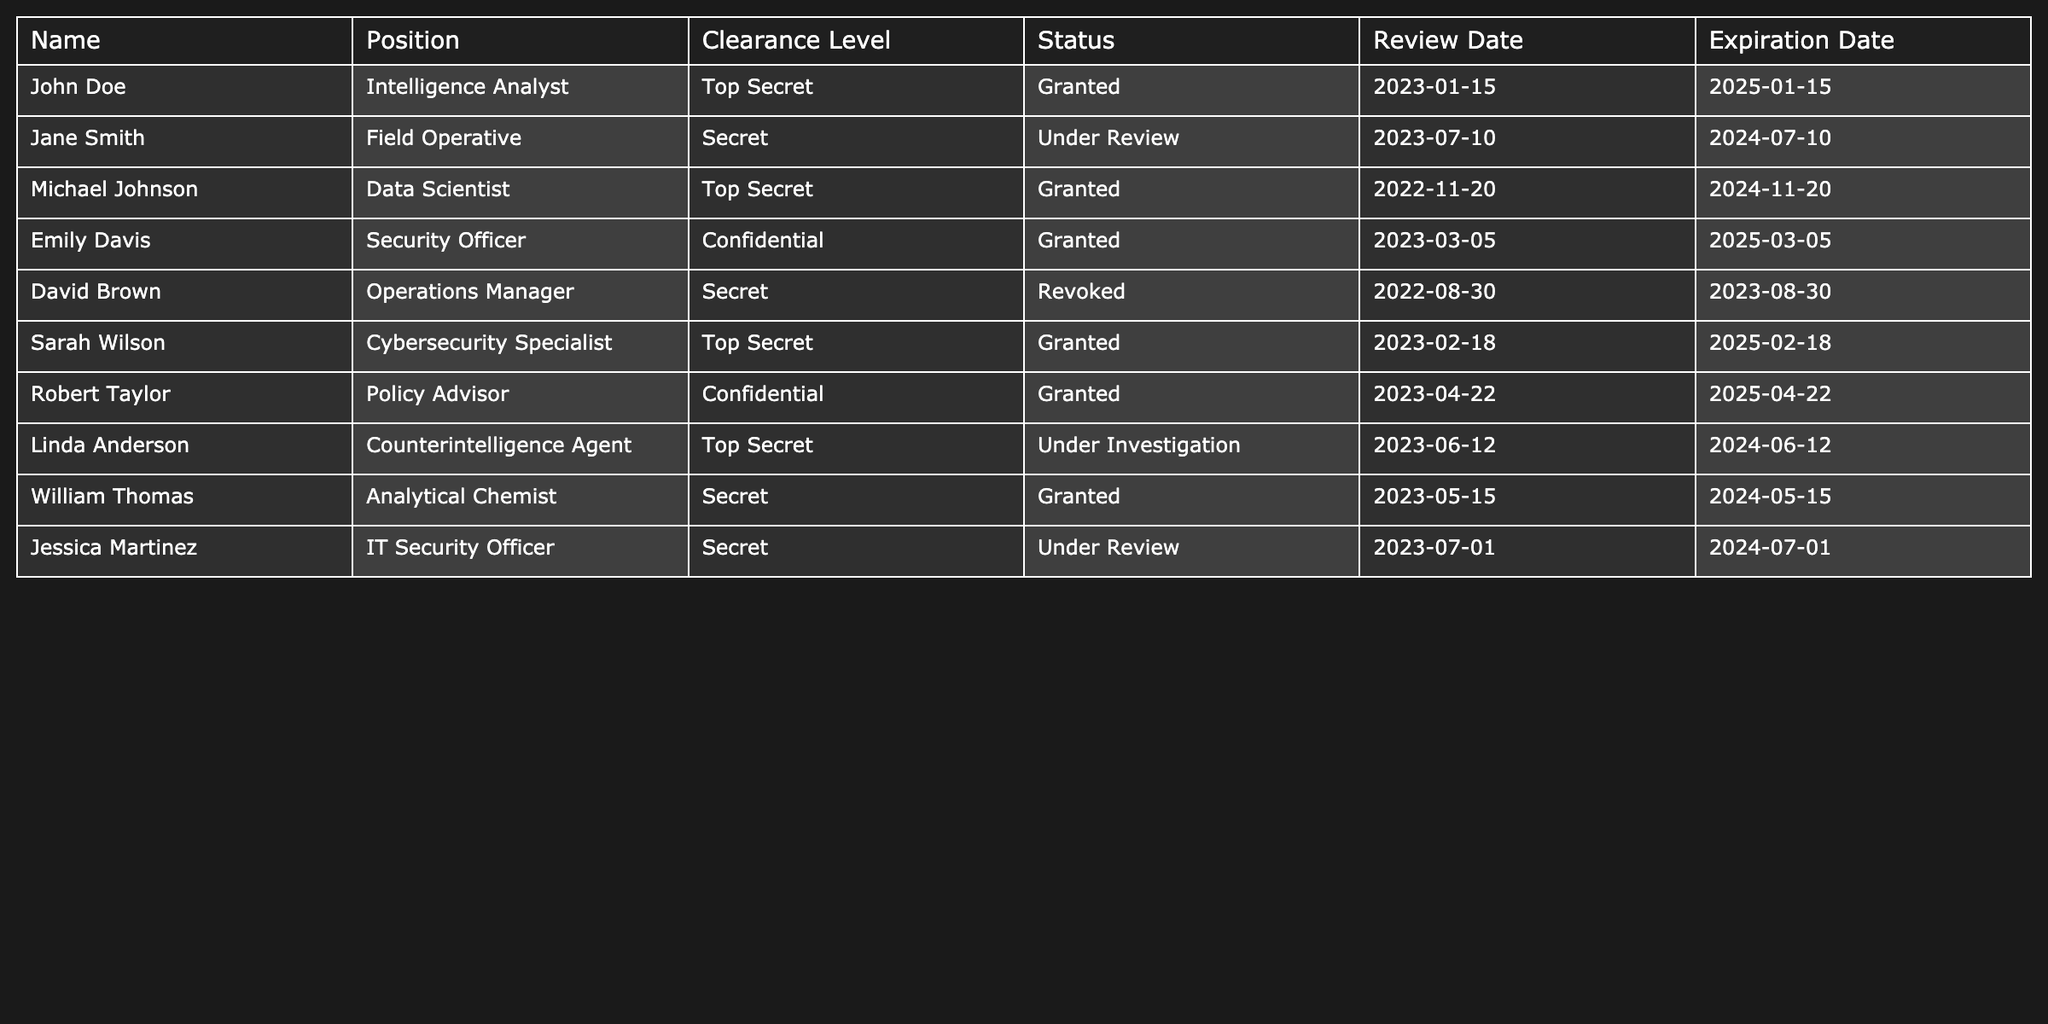What is the clearance level of Emily Davis? The table indicates that Emily Davis holds the position of Security Officer, and her clearance level is listed as Confidential.
Answer: Confidential How many personnel have a clearance status of 'Granted'? By reviewing the table, I can count the entries where the status is 'Granted'. Those personnel are John Doe, Michael Johnson, Emily Davis, Sarah Wilson, Robert Taylor, and William Thomas, making a total of 6 individuals.
Answer: 6 Is there any personnel with a clearance status of 'Revoked'? Scanning through the status column, I see that David Brown has a status marked as 'Revoked'. Therefore, the answer is yes.
Answer: Yes Who has the latest review date? When checking the review dates, I find that Jane Smith has a review date of 2023-07-10, which is the latest date compared to others in the table.
Answer: Jane Smith What is the clearance level of personnel who have their clearance status under review? The individuals with 'Under Review' status are Jane Smith and Jessica Martinez, both having a clearance level of Secret.
Answer: Secret How many personnel have a clearance level of Top Secret? The table displays John Doe, Michael Johnson, Sarah Wilson, and Linda Anderson as having Top Secret clearance. Counting these gives us a total of 4 personnel.
Answer: 4 What is the difference in expiration dates between John Doe and David Brown? John's expiration date is 2025-01-15, while David's is 2023-08-30. Calculating the difference means counting the number of months and days between these dates yields an approximate difference of 1 year and 5 months.
Answer: 1 year and 5 months Are there any personnel whose clearance is set to expire this year? Checking the expiration dates, David Brown's clearance expires in 2023-08-30. Therefore, the answer is yes; at least one personnel's clearance is set to expire this year.
Answer: Yes Which clearance level has the most personnel? By counting the number of entries for each clearance level, 'Top Secret' has 4 personnel, 'Secret' has 3, and 'Confidential' has 2. Hence, 'Top Secret' has the most personnel.
Answer: Top Secret What is the percentage of personnel with 'Under Investigation' status? There are 10 personnel total, and only Linda Anderson is 'Under Investigation'. Calculating the percentage gives (1/10) * 100 = 10%.
Answer: 10% 